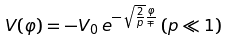Convert formula to latex. <formula><loc_0><loc_0><loc_500><loc_500>V ( \varphi ) = - V _ { 0 } \, e ^ { - \sqrt { \frac { 2 } { p } } \frac { \varphi } { \mp } } \, ( p \ll 1 )</formula> 